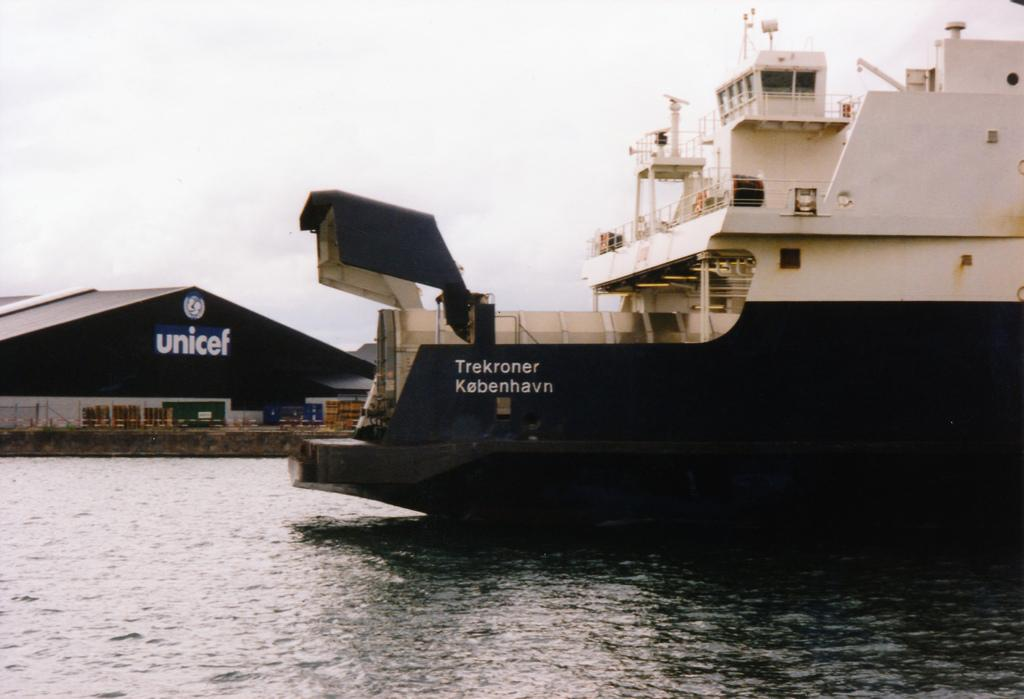<image>
Present a compact description of the photo's key features. A large ship is docked by a building that says unicef. 